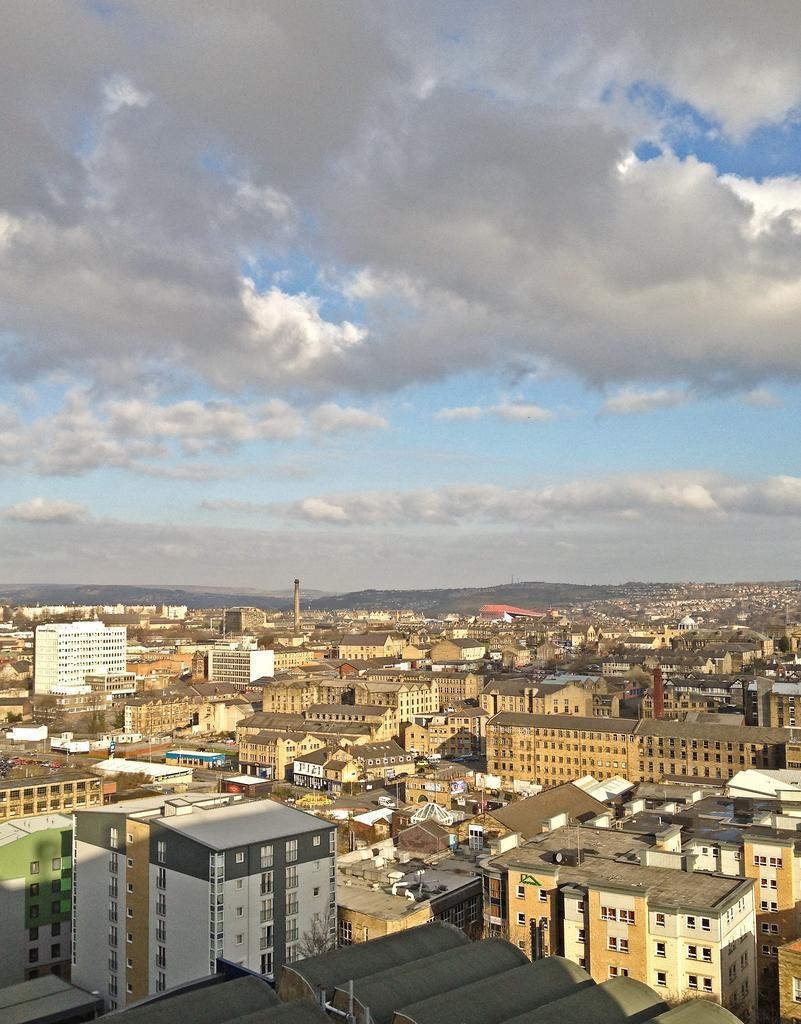Please provide a concise description of this image. In this image, we can see some buildings. There are clouds in the sky. 